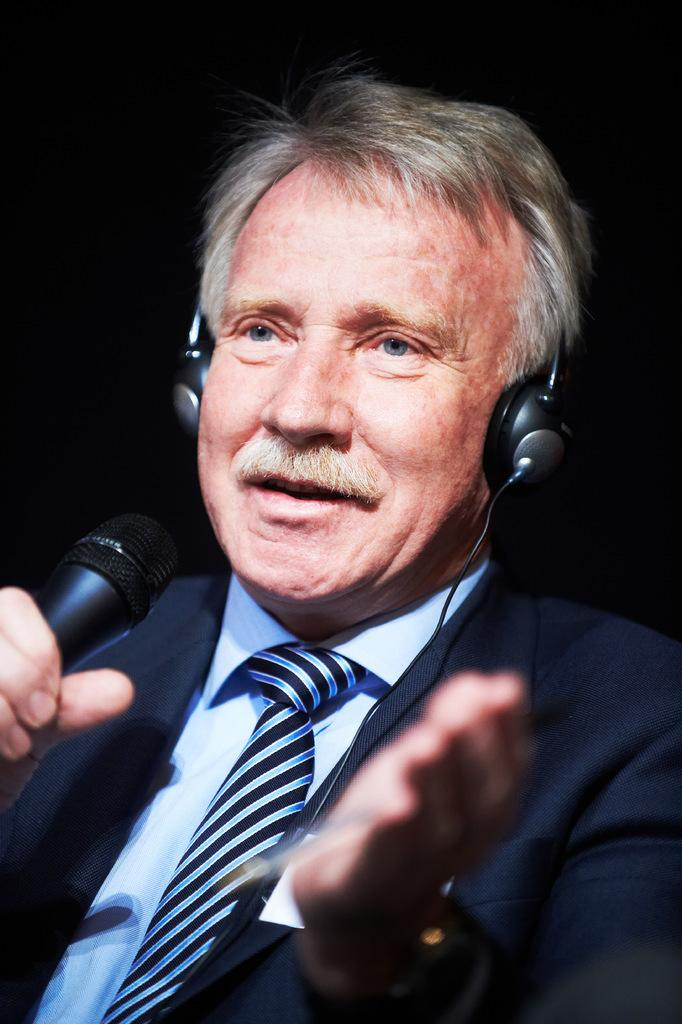What is the main subject of the image? The main subject of the image is a man. What type of clothing is the man wearing? The man is wearing a suit, a shirt, and a tie. What accessory is the man wearing on his head? The man is wearing a headset. What object is the man holding in his hand? The man is holding a microphone. What type of toothbrush is the man using in the image? There is no toothbrush present in the image. Who is the creator of the suit the man is wearing? The facts provided do not mention the creator of the suit, so it cannot be determined from the image. 